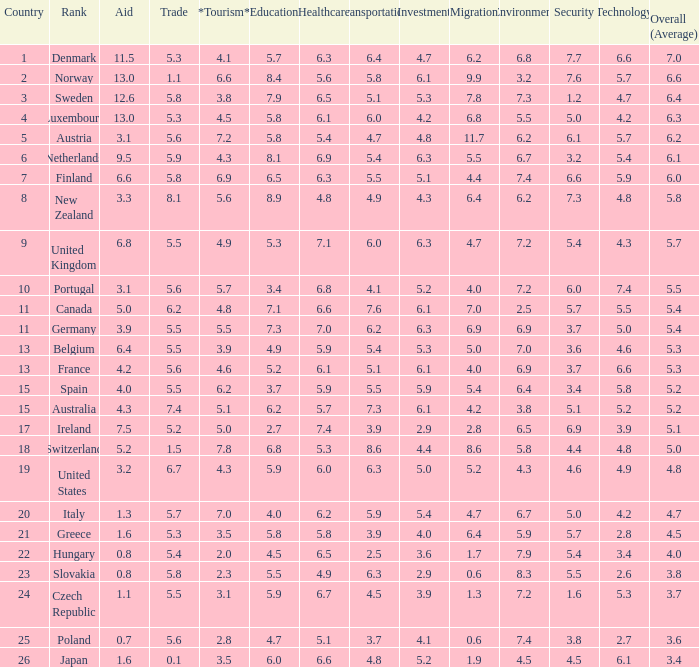How many times is denmark ranked in technology? 1.0. 